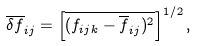Convert formula to latex. <formula><loc_0><loc_0><loc_500><loc_500>\overline { \delta f } _ { i j } = \left [ \overline { ( f _ { i j k } - \overline { f } _ { i j } ) ^ { 2 } } \right ] ^ { 1 / 2 } ,</formula> 